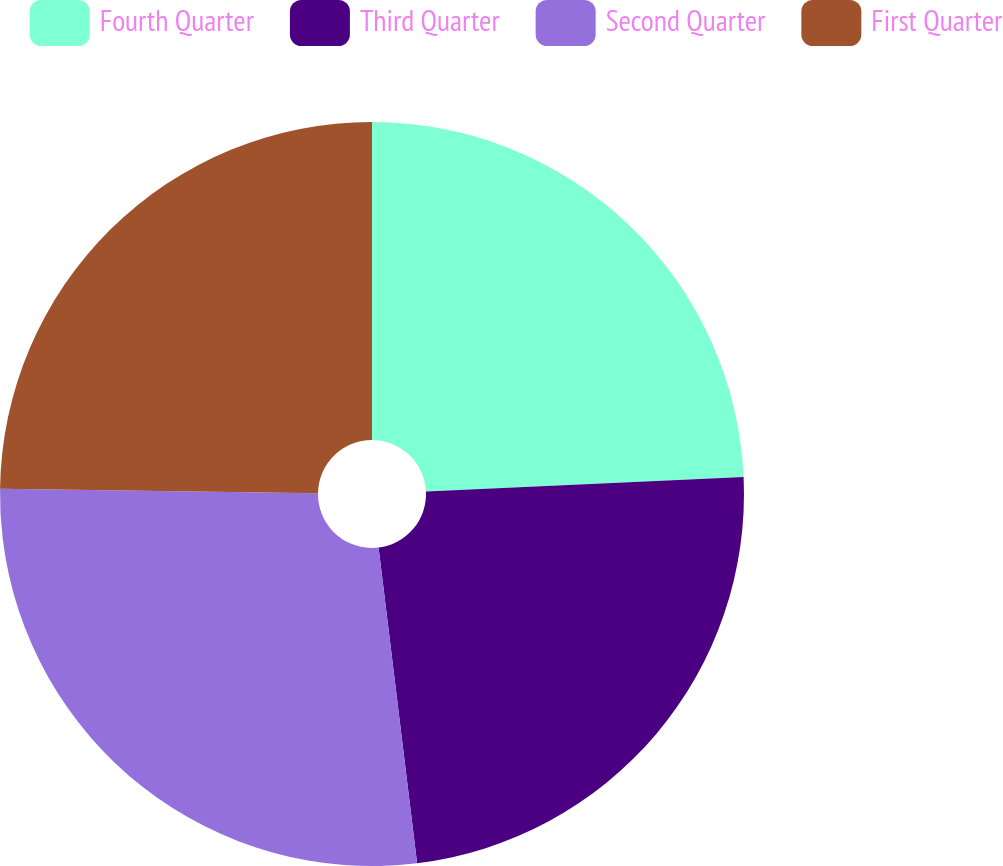Convert chart to OTSL. <chart><loc_0><loc_0><loc_500><loc_500><pie_chart><fcel>Fourth Quarter<fcel>Third Quarter<fcel>Second Quarter<fcel>First Quarter<nl><fcel>24.27%<fcel>23.79%<fcel>27.16%<fcel>24.77%<nl></chart> 